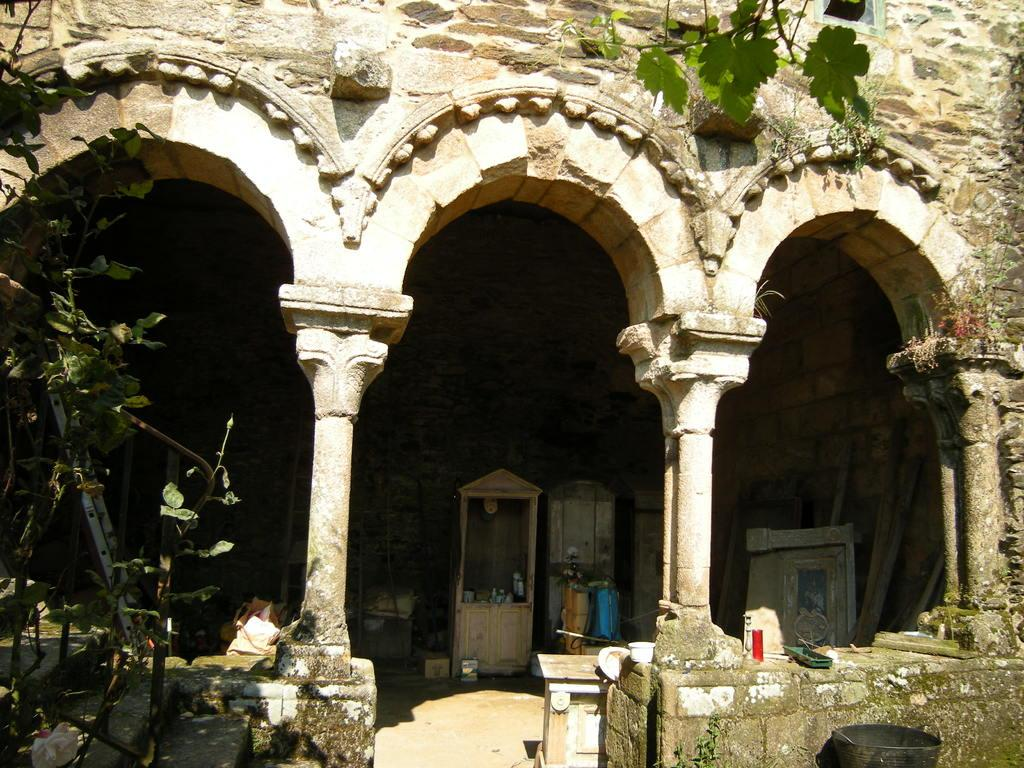What type of architectural features are present on the building in the image? The building in the image has arches and pillars. What can be seen in the image besides the building? There are plants in the image. What is inside the building? Inside the building, there is a shelf and wooden pieces, as well as many other items. Where is the box located in relation to the building? Near the building, there is a box. What type of voice can be heard coming from the building in the image? There is no indication of any sound or voice in the image, so it cannot be determined. 